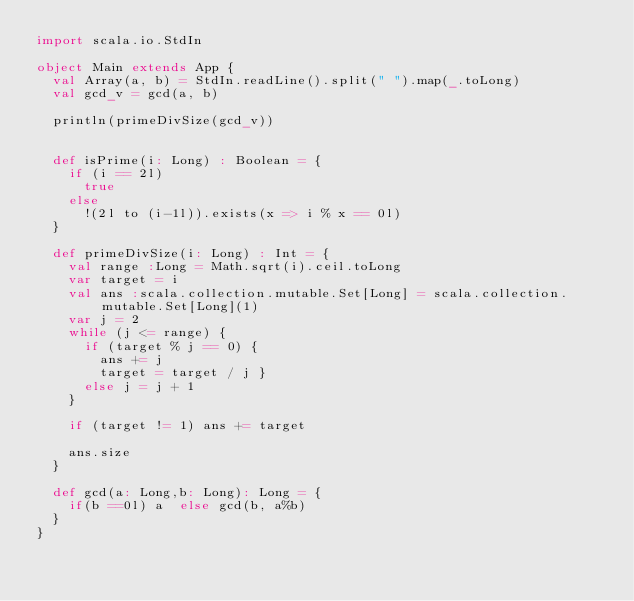<code> <loc_0><loc_0><loc_500><loc_500><_Scala_>import scala.io.StdIn

object Main extends App {
  val Array(a, b) = StdIn.readLine().split(" ").map(_.toLong)
  val gcd_v = gcd(a, b)

  println(primeDivSize(gcd_v))
  

  def isPrime(i: Long) : Boolean = {
    if (i == 2l)
      true
    else
      !(2l to (i-1l)).exists(x => i % x == 0l)
  }

  def primeDivSize(i: Long) : Int = {
    val range :Long = Math.sqrt(i).ceil.toLong
    var target = i
    val ans :scala.collection.mutable.Set[Long] = scala.collection.mutable.Set[Long](1)
    var j = 2
    while (j <= range) {
      if (target % j == 0) {
        ans += j
        target = target / j }
      else j = j + 1
    }

    if (target != 1) ans += target

    ans.size
  }
  
  def gcd(a: Long,b: Long): Long = {
    if(b ==0l) a  else gcd(b, a%b)
  }
}
  

</code> 